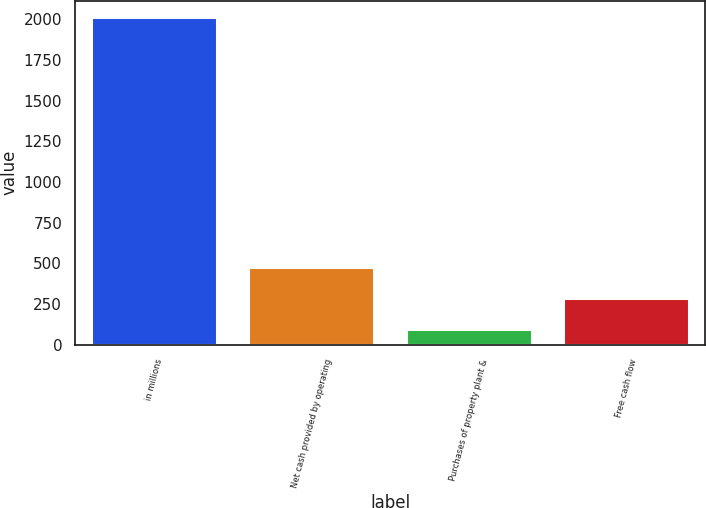Convert chart to OTSL. <chart><loc_0><loc_0><loc_500><loc_500><bar_chart><fcel>in millions<fcel>Net cash provided by operating<fcel>Purchases of property plant &<fcel>Free cash flow<nl><fcel>2012<fcel>477.12<fcel>93.4<fcel>285.26<nl></chart> 